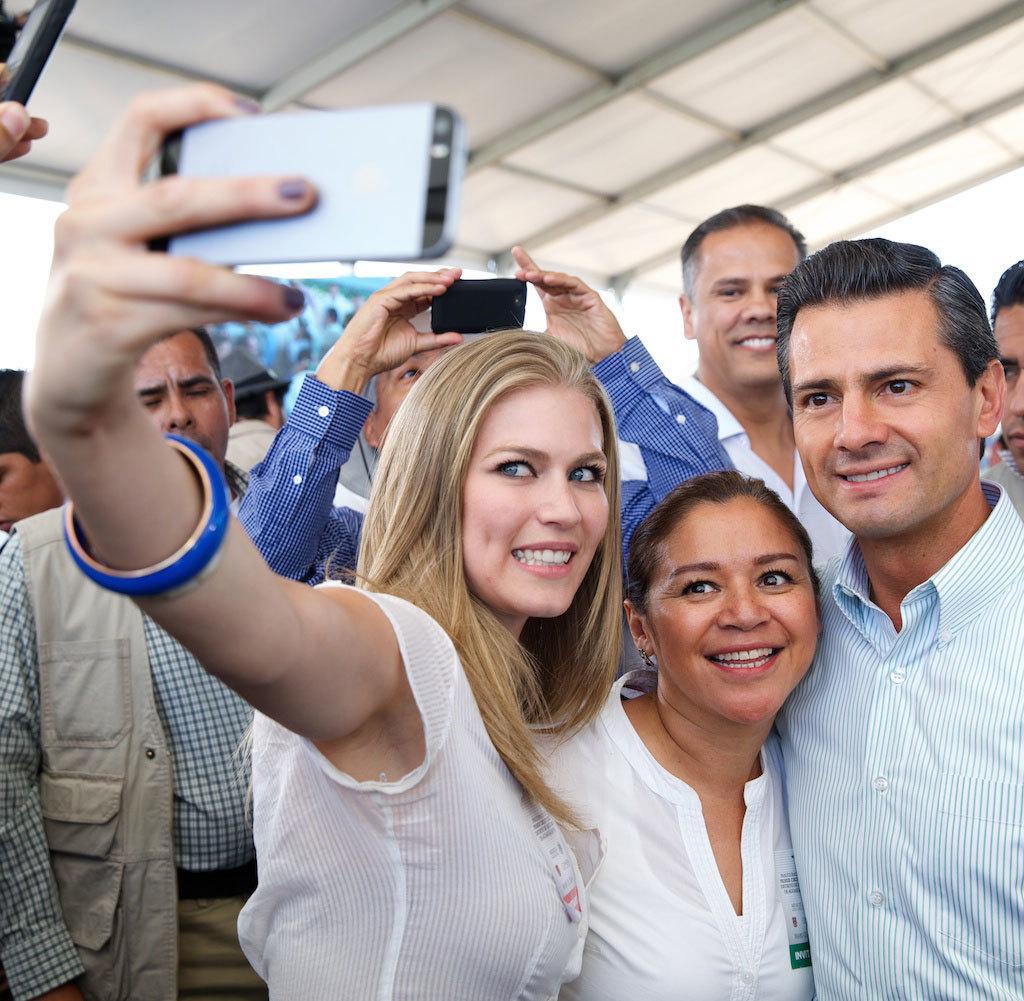Describe this image in one or two sentences. In this picture there are three people here. Two of them were women. One of them was man. The woman in the left side is clicking a selfie with her mobile. In the background there are some people standing and a guy is taking a picture with his mobile. 